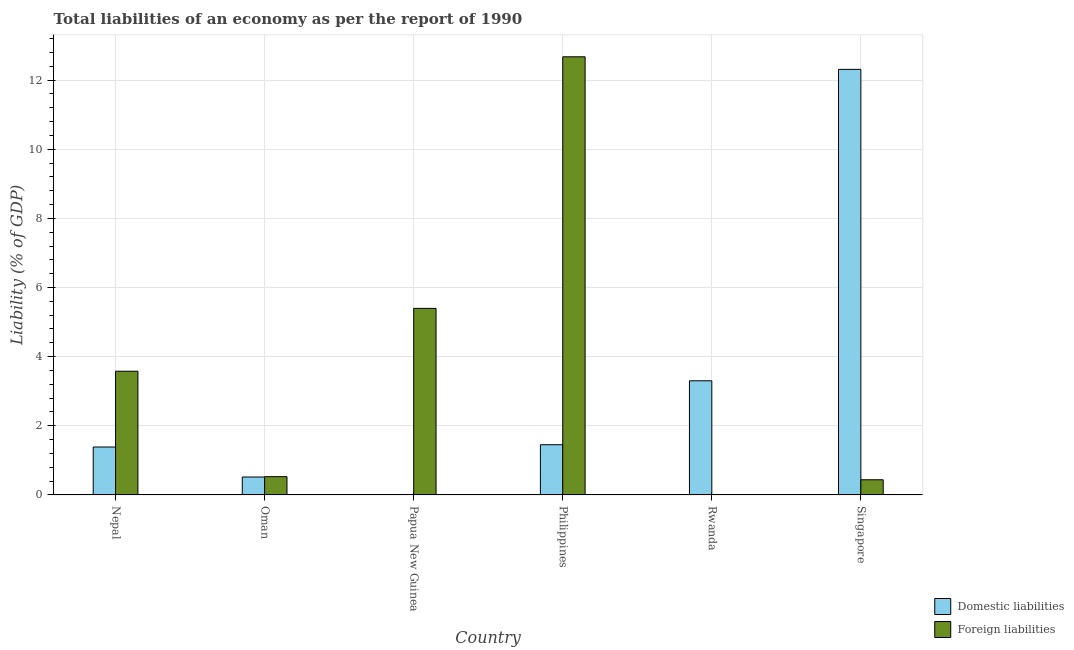How many bars are there on the 1st tick from the left?
Your response must be concise. 2. How many bars are there on the 2nd tick from the right?
Keep it short and to the point. 1. What is the label of the 5th group of bars from the left?
Offer a terse response. Rwanda. In how many cases, is the number of bars for a given country not equal to the number of legend labels?
Ensure brevity in your answer.  2. What is the incurrence of foreign liabilities in Philippines?
Your answer should be very brief. 12.67. Across all countries, what is the maximum incurrence of domestic liabilities?
Give a very brief answer. 12.31. In which country was the incurrence of domestic liabilities maximum?
Give a very brief answer. Singapore. What is the total incurrence of foreign liabilities in the graph?
Your answer should be compact. 22.62. What is the difference between the incurrence of domestic liabilities in Nepal and that in Singapore?
Offer a terse response. -10.92. What is the difference between the incurrence of foreign liabilities in Singapore and the incurrence of domestic liabilities in Papua New Guinea?
Keep it short and to the point. 0.44. What is the average incurrence of domestic liabilities per country?
Your answer should be compact. 3.16. What is the difference between the incurrence of foreign liabilities and incurrence of domestic liabilities in Philippines?
Your answer should be compact. 11.22. What is the ratio of the incurrence of domestic liabilities in Nepal to that in Rwanda?
Offer a terse response. 0.42. Is the incurrence of domestic liabilities in Nepal less than that in Philippines?
Provide a short and direct response. Yes. What is the difference between the highest and the second highest incurrence of domestic liabilities?
Your answer should be compact. 9.01. What is the difference between the highest and the lowest incurrence of domestic liabilities?
Ensure brevity in your answer.  12.31. Is the sum of the incurrence of domestic liabilities in Nepal and Singapore greater than the maximum incurrence of foreign liabilities across all countries?
Your response must be concise. Yes. How many countries are there in the graph?
Your response must be concise. 6. Does the graph contain any zero values?
Your answer should be compact. Yes. What is the title of the graph?
Your answer should be compact. Total liabilities of an economy as per the report of 1990. What is the label or title of the X-axis?
Offer a terse response. Country. What is the label or title of the Y-axis?
Provide a succinct answer. Liability (% of GDP). What is the Liability (% of GDP) in Domestic liabilities in Nepal?
Your response must be concise. 1.39. What is the Liability (% of GDP) in Foreign liabilities in Nepal?
Your response must be concise. 3.58. What is the Liability (% of GDP) in Domestic liabilities in Oman?
Your answer should be compact. 0.52. What is the Liability (% of GDP) of Foreign liabilities in Oman?
Give a very brief answer. 0.53. What is the Liability (% of GDP) in Foreign liabilities in Papua New Guinea?
Offer a very short reply. 5.4. What is the Liability (% of GDP) of Domestic liabilities in Philippines?
Your response must be concise. 1.45. What is the Liability (% of GDP) in Foreign liabilities in Philippines?
Your answer should be compact. 12.67. What is the Liability (% of GDP) of Domestic liabilities in Rwanda?
Your response must be concise. 3.3. What is the Liability (% of GDP) in Foreign liabilities in Rwanda?
Your response must be concise. 0. What is the Liability (% of GDP) in Domestic liabilities in Singapore?
Your response must be concise. 12.31. What is the Liability (% of GDP) in Foreign liabilities in Singapore?
Your answer should be compact. 0.44. Across all countries, what is the maximum Liability (% of GDP) in Domestic liabilities?
Offer a very short reply. 12.31. Across all countries, what is the maximum Liability (% of GDP) in Foreign liabilities?
Make the answer very short. 12.67. What is the total Liability (% of GDP) in Domestic liabilities in the graph?
Offer a terse response. 18.97. What is the total Liability (% of GDP) in Foreign liabilities in the graph?
Your answer should be very brief. 22.62. What is the difference between the Liability (% of GDP) in Domestic liabilities in Nepal and that in Oman?
Provide a short and direct response. 0.87. What is the difference between the Liability (% of GDP) of Foreign liabilities in Nepal and that in Oman?
Ensure brevity in your answer.  3.05. What is the difference between the Liability (% of GDP) of Foreign liabilities in Nepal and that in Papua New Guinea?
Give a very brief answer. -1.82. What is the difference between the Liability (% of GDP) of Domestic liabilities in Nepal and that in Philippines?
Make the answer very short. -0.07. What is the difference between the Liability (% of GDP) of Foreign liabilities in Nepal and that in Philippines?
Offer a terse response. -9.1. What is the difference between the Liability (% of GDP) in Domestic liabilities in Nepal and that in Rwanda?
Provide a succinct answer. -1.92. What is the difference between the Liability (% of GDP) of Domestic liabilities in Nepal and that in Singapore?
Provide a short and direct response. -10.92. What is the difference between the Liability (% of GDP) of Foreign liabilities in Nepal and that in Singapore?
Provide a succinct answer. 3.14. What is the difference between the Liability (% of GDP) in Foreign liabilities in Oman and that in Papua New Guinea?
Offer a very short reply. -4.87. What is the difference between the Liability (% of GDP) of Domestic liabilities in Oman and that in Philippines?
Your response must be concise. -0.93. What is the difference between the Liability (% of GDP) of Foreign liabilities in Oman and that in Philippines?
Make the answer very short. -12.15. What is the difference between the Liability (% of GDP) in Domestic liabilities in Oman and that in Rwanda?
Give a very brief answer. -2.78. What is the difference between the Liability (% of GDP) of Domestic liabilities in Oman and that in Singapore?
Your response must be concise. -11.79. What is the difference between the Liability (% of GDP) in Foreign liabilities in Oman and that in Singapore?
Provide a succinct answer. 0.09. What is the difference between the Liability (% of GDP) of Foreign liabilities in Papua New Guinea and that in Philippines?
Your answer should be very brief. -7.28. What is the difference between the Liability (% of GDP) in Foreign liabilities in Papua New Guinea and that in Singapore?
Provide a short and direct response. 4.96. What is the difference between the Liability (% of GDP) in Domestic liabilities in Philippines and that in Rwanda?
Keep it short and to the point. -1.85. What is the difference between the Liability (% of GDP) of Domestic liabilities in Philippines and that in Singapore?
Provide a short and direct response. -10.86. What is the difference between the Liability (% of GDP) of Foreign liabilities in Philippines and that in Singapore?
Keep it short and to the point. 12.23. What is the difference between the Liability (% of GDP) in Domestic liabilities in Rwanda and that in Singapore?
Offer a terse response. -9.01. What is the difference between the Liability (% of GDP) in Domestic liabilities in Nepal and the Liability (% of GDP) in Foreign liabilities in Oman?
Provide a short and direct response. 0.86. What is the difference between the Liability (% of GDP) in Domestic liabilities in Nepal and the Liability (% of GDP) in Foreign liabilities in Papua New Guinea?
Ensure brevity in your answer.  -4.01. What is the difference between the Liability (% of GDP) in Domestic liabilities in Nepal and the Liability (% of GDP) in Foreign liabilities in Philippines?
Offer a very short reply. -11.29. What is the difference between the Liability (% of GDP) in Domestic liabilities in Nepal and the Liability (% of GDP) in Foreign liabilities in Singapore?
Your answer should be compact. 0.95. What is the difference between the Liability (% of GDP) of Domestic liabilities in Oman and the Liability (% of GDP) of Foreign liabilities in Papua New Guinea?
Your answer should be very brief. -4.88. What is the difference between the Liability (% of GDP) of Domestic liabilities in Oman and the Liability (% of GDP) of Foreign liabilities in Philippines?
Ensure brevity in your answer.  -12.16. What is the difference between the Liability (% of GDP) in Domestic liabilities in Oman and the Liability (% of GDP) in Foreign liabilities in Singapore?
Ensure brevity in your answer.  0.08. What is the difference between the Liability (% of GDP) in Domestic liabilities in Philippines and the Liability (% of GDP) in Foreign liabilities in Singapore?
Ensure brevity in your answer.  1.01. What is the difference between the Liability (% of GDP) in Domestic liabilities in Rwanda and the Liability (% of GDP) in Foreign liabilities in Singapore?
Offer a terse response. 2.86. What is the average Liability (% of GDP) in Domestic liabilities per country?
Ensure brevity in your answer.  3.16. What is the average Liability (% of GDP) of Foreign liabilities per country?
Offer a very short reply. 3.77. What is the difference between the Liability (% of GDP) in Domestic liabilities and Liability (% of GDP) in Foreign liabilities in Nepal?
Keep it short and to the point. -2.19. What is the difference between the Liability (% of GDP) in Domestic liabilities and Liability (% of GDP) in Foreign liabilities in Oman?
Ensure brevity in your answer.  -0.01. What is the difference between the Liability (% of GDP) in Domestic liabilities and Liability (% of GDP) in Foreign liabilities in Philippines?
Provide a succinct answer. -11.22. What is the difference between the Liability (% of GDP) of Domestic liabilities and Liability (% of GDP) of Foreign liabilities in Singapore?
Make the answer very short. 11.87. What is the ratio of the Liability (% of GDP) of Domestic liabilities in Nepal to that in Oman?
Your answer should be compact. 2.67. What is the ratio of the Liability (% of GDP) of Foreign liabilities in Nepal to that in Oman?
Make the answer very short. 6.77. What is the ratio of the Liability (% of GDP) of Foreign liabilities in Nepal to that in Papua New Guinea?
Your response must be concise. 0.66. What is the ratio of the Liability (% of GDP) in Domestic liabilities in Nepal to that in Philippines?
Your response must be concise. 0.95. What is the ratio of the Liability (% of GDP) of Foreign liabilities in Nepal to that in Philippines?
Provide a short and direct response. 0.28. What is the ratio of the Liability (% of GDP) in Domestic liabilities in Nepal to that in Rwanda?
Offer a very short reply. 0.42. What is the ratio of the Liability (% of GDP) in Domestic liabilities in Nepal to that in Singapore?
Keep it short and to the point. 0.11. What is the ratio of the Liability (% of GDP) in Foreign liabilities in Nepal to that in Singapore?
Your answer should be very brief. 8.15. What is the ratio of the Liability (% of GDP) in Foreign liabilities in Oman to that in Papua New Guinea?
Provide a short and direct response. 0.1. What is the ratio of the Liability (% of GDP) of Domestic liabilities in Oman to that in Philippines?
Provide a succinct answer. 0.36. What is the ratio of the Liability (% of GDP) of Foreign liabilities in Oman to that in Philippines?
Provide a succinct answer. 0.04. What is the ratio of the Liability (% of GDP) in Domestic liabilities in Oman to that in Rwanda?
Provide a succinct answer. 0.16. What is the ratio of the Liability (% of GDP) of Domestic liabilities in Oman to that in Singapore?
Provide a succinct answer. 0.04. What is the ratio of the Liability (% of GDP) of Foreign liabilities in Oman to that in Singapore?
Your response must be concise. 1.2. What is the ratio of the Liability (% of GDP) of Foreign liabilities in Papua New Guinea to that in Philippines?
Keep it short and to the point. 0.43. What is the ratio of the Liability (% of GDP) of Foreign liabilities in Papua New Guinea to that in Singapore?
Ensure brevity in your answer.  12.3. What is the ratio of the Liability (% of GDP) of Domestic liabilities in Philippines to that in Rwanda?
Your answer should be very brief. 0.44. What is the ratio of the Liability (% of GDP) in Domestic liabilities in Philippines to that in Singapore?
Offer a terse response. 0.12. What is the ratio of the Liability (% of GDP) of Foreign liabilities in Philippines to that in Singapore?
Your answer should be very brief. 28.88. What is the ratio of the Liability (% of GDP) of Domestic liabilities in Rwanda to that in Singapore?
Provide a succinct answer. 0.27. What is the difference between the highest and the second highest Liability (% of GDP) in Domestic liabilities?
Your answer should be compact. 9.01. What is the difference between the highest and the second highest Liability (% of GDP) of Foreign liabilities?
Provide a succinct answer. 7.28. What is the difference between the highest and the lowest Liability (% of GDP) in Domestic liabilities?
Make the answer very short. 12.31. What is the difference between the highest and the lowest Liability (% of GDP) of Foreign liabilities?
Your answer should be very brief. 12.67. 